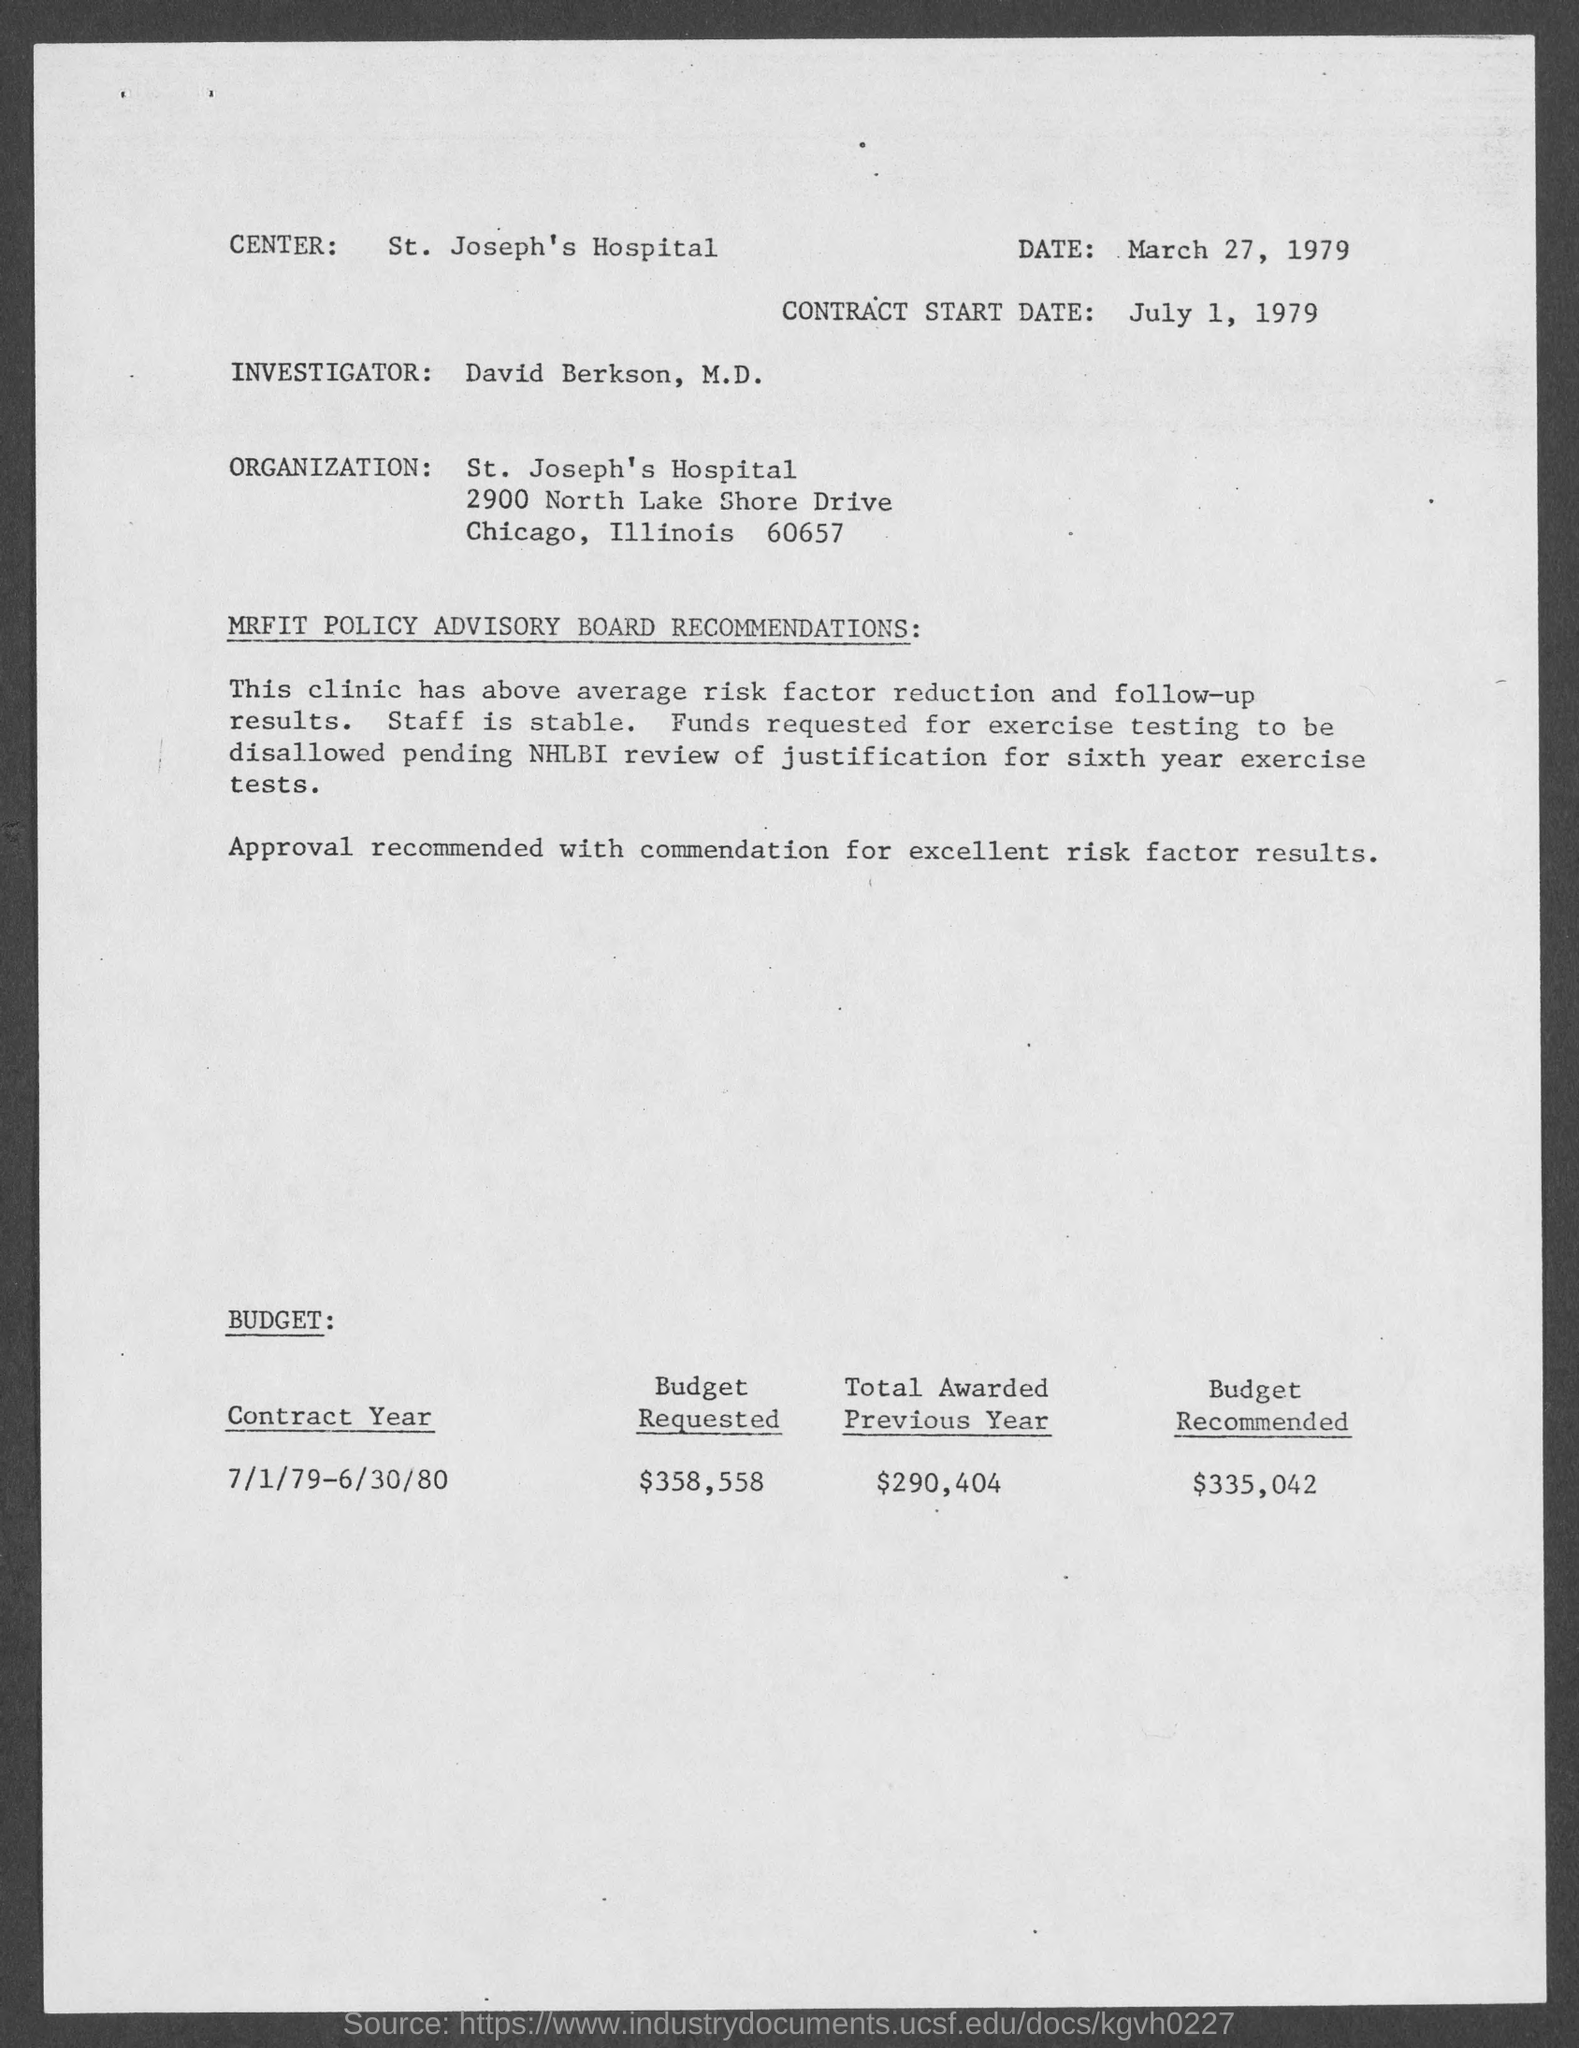Indicate a few pertinent items in this graphic. According to the information provided on the given page, the contract start date is July 1, 1979. The date mentioned in the given page is March 27, 1979. The organization mentioned on the given page is St. Joseph's Hospital. The total amount awarded in the previous year, as mentioned on the given page, was $290,404. The recommended budget amount is $335,042, as mentioned in the given page. 